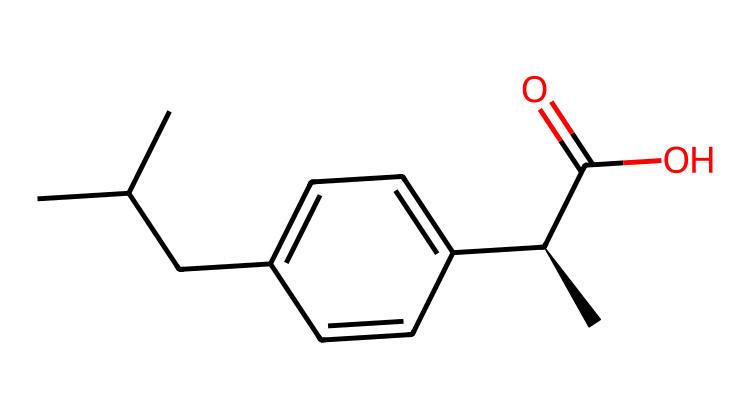What is the molecular formula of ibuprofen? To determine the molecular formula, count the number of carbon (C), hydrogen (H), and oxygen (O) atoms in the provided SMILES. The molecule has 13 carbon atoms, 18 hydrogen atoms, and 2 oxygen atoms, resulting in the formula C13H18O2.
Answer: C13H18O2 How many chiral centers are present in ibuprofen? By examining the structure represented in the SMILES, I find that there is one chiral carbon indicated by the symbol [C@H] which specifies the stereochemistry. Therefore, there is one chiral center in the molecule.
Answer: 1 What type of functional group is present in ibuprofen? In the structure, the -C(=O)O indicates a carboxylic acid functional group, as it consists of a carbonyl (C=O) and a hydroxyl (O) group attached to the same carbon atom.
Answer: carboxylic acid What is the total number of double bonds in ibuprofen? The SMILES representation does not show any double bonds outside of the carbonyl (C=O) in the carboxylic acid group; hence there is one double bond in the molecule related to the functional group.
Answer: 1 What is the primary functional activity of ibuprofen as an anti-inflammatory? The carboxylic acid group is crucial for the anti-inflammatory activity since it binds to the cyclooxygenase enzymes, inhibiting prostaglandin synthesis.
Answer: anti-inflammatory Which part of the molecule contributes to its pain relief properties? The carboxylic acid group plays a significant role by interacting with various enzymes involved in pain signaling pathways, helping to reduce inflammation and provide pain relief.
Answer: carboxylic acid 